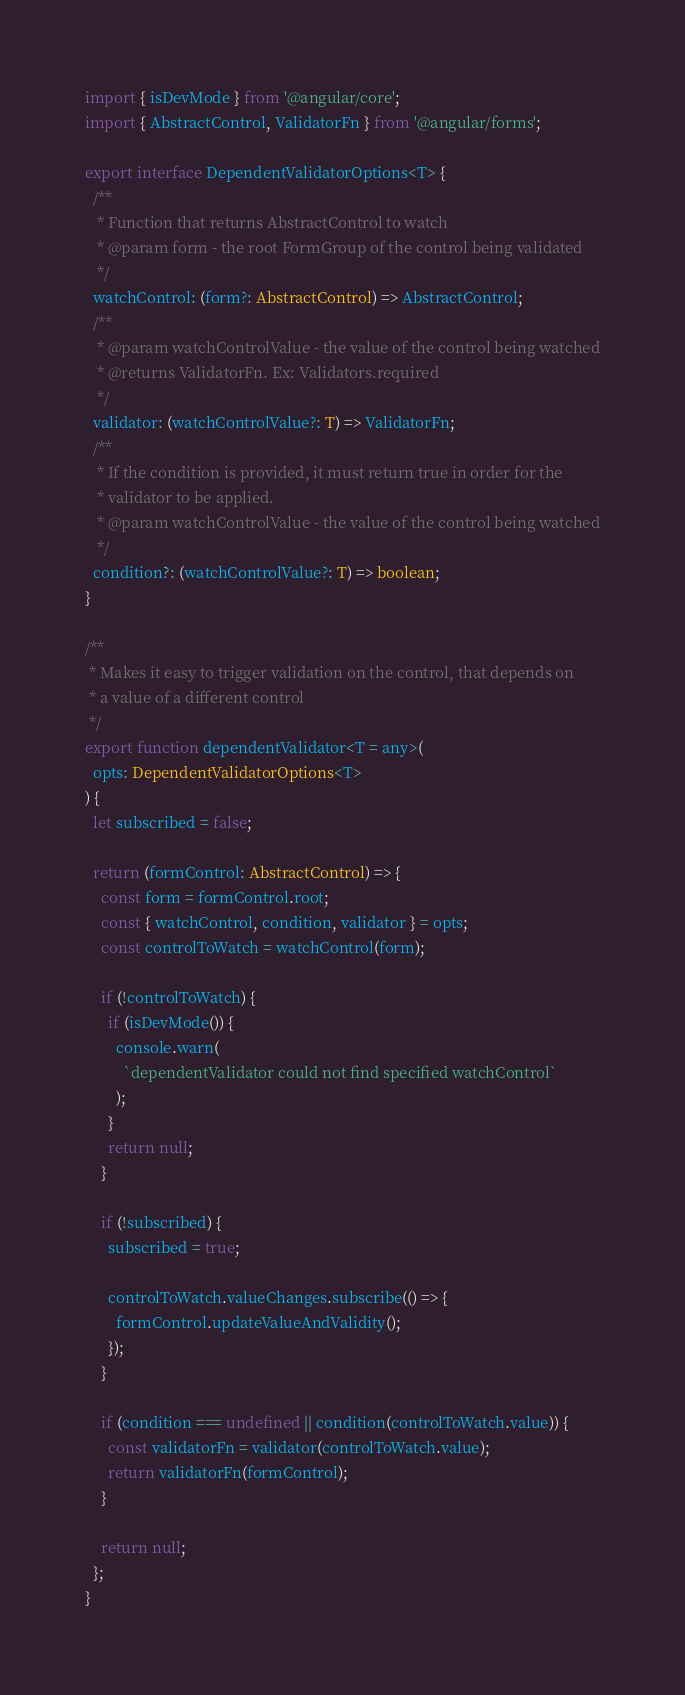<code> <loc_0><loc_0><loc_500><loc_500><_TypeScript_>import { isDevMode } from '@angular/core';
import { AbstractControl, ValidatorFn } from '@angular/forms';

export interface DependentValidatorOptions<T> {
  /**
   * Function that returns AbstractControl to watch
   * @param form - the root FormGroup of the control being validated
   */
  watchControl: (form?: AbstractControl) => AbstractControl;
  /**
   * @param watchControlValue - the value of the control being watched
   * @returns ValidatorFn. Ex: Validators.required
   */
  validator: (watchControlValue?: T) => ValidatorFn;
  /**
   * If the condition is provided, it must return true in order for the
   * validator to be applied.
   * @param watchControlValue - the value of the control being watched
   */
  condition?: (watchControlValue?: T) => boolean;
}

/**
 * Makes it easy to trigger validation on the control, that depends on
 * a value of a different control
 */
export function dependentValidator<T = any>(
  opts: DependentValidatorOptions<T>
) {
  let subscribed = false;

  return (formControl: AbstractControl) => {
    const form = formControl.root;
    const { watchControl, condition, validator } = opts;
    const controlToWatch = watchControl(form);

    if (!controlToWatch) {
      if (isDevMode()) {
        console.warn(
          `dependentValidator could not find specified watchControl`
        );
      }
      return null;
    }

    if (!subscribed) {
      subscribed = true;

      controlToWatch.valueChanges.subscribe(() => {
        formControl.updateValueAndValidity();
      });
    }

    if (condition === undefined || condition(controlToWatch.value)) {
      const validatorFn = validator(controlToWatch.value);
      return validatorFn(formControl);
    }

    return null;
  };
}
</code> 